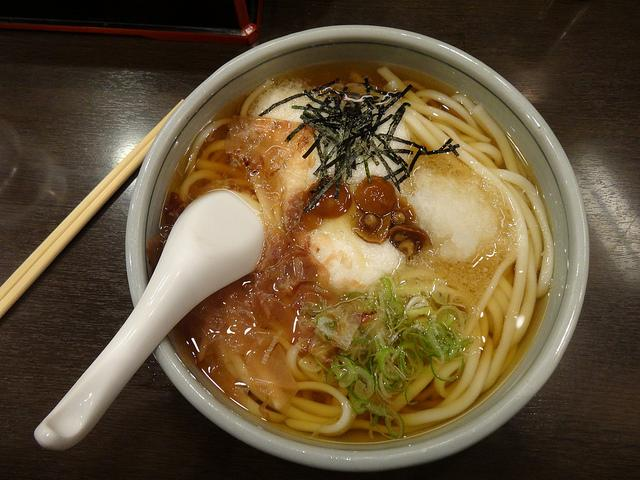What is the bowl made from? Please explain your reasoning. glass. It is breakable. 